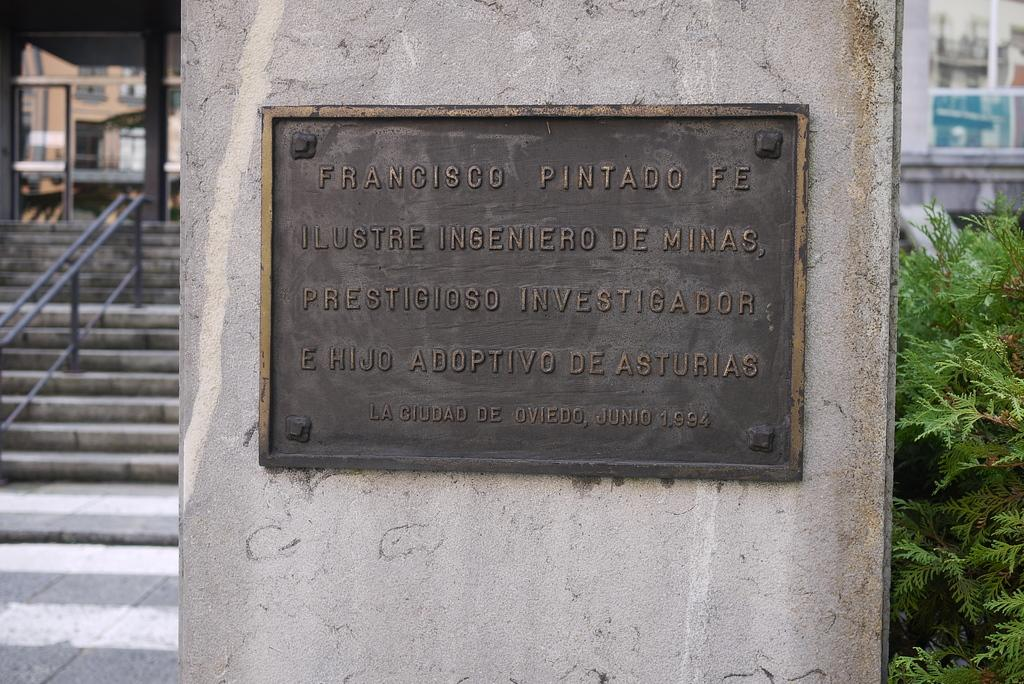What is present on the wall in the image? There is a board with text on the wall. What type of stairs are located beside the wall? There are concrete stairs beside the wall. What kind of fence can be seen in the image? There is an iron pole fence in the image. What type of vegetation is present in the image? There is a plant in the image. Can you describe the structure that the wall and stairs might be part of? There may be a building in the image. Can you tell me how the river flows in the image? There is no river present in the image. What type of cast is visible on the plant in the image? There is no cast present on the plant in the image. 